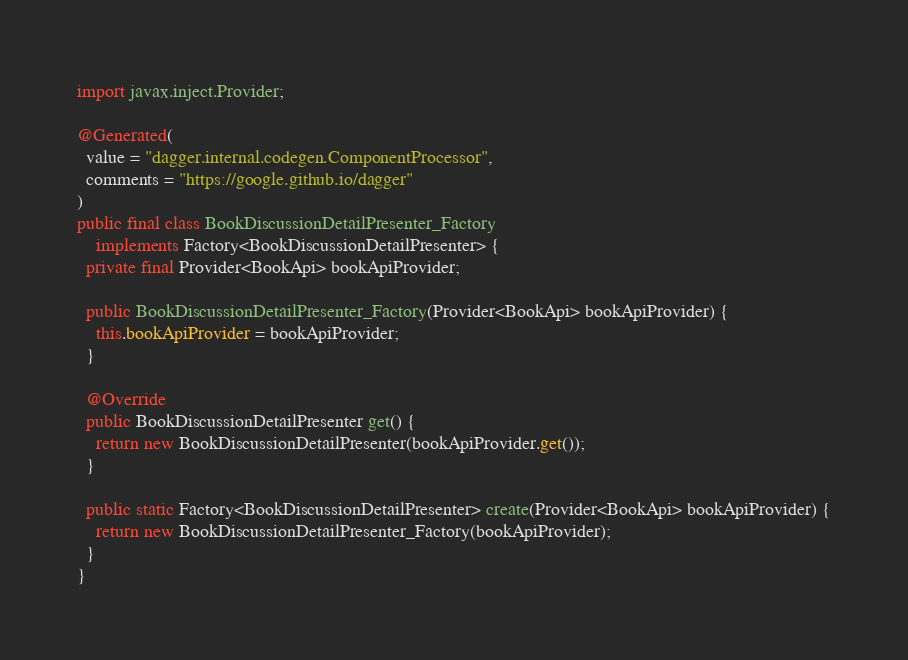<code> <loc_0><loc_0><loc_500><loc_500><_Java_>import javax.inject.Provider;

@Generated(
  value = "dagger.internal.codegen.ComponentProcessor",
  comments = "https://google.github.io/dagger"
)
public final class BookDiscussionDetailPresenter_Factory
    implements Factory<BookDiscussionDetailPresenter> {
  private final Provider<BookApi> bookApiProvider;

  public BookDiscussionDetailPresenter_Factory(Provider<BookApi> bookApiProvider) {
    this.bookApiProvider = bookApiProvider;
  }

  @Override
  public BookDiscussionDetailPresenter get() {
    return new BookDiscussionDetailPresenter(bookApiProvider.get());
  }

  public static Factory<BookDiscussionDetailPresenter> create(Provider<BookApi> bookApiProvider) {
    return new BookDiscussionDetailPresenter_Factory(bookApiProvider);
  }
}
</code> 